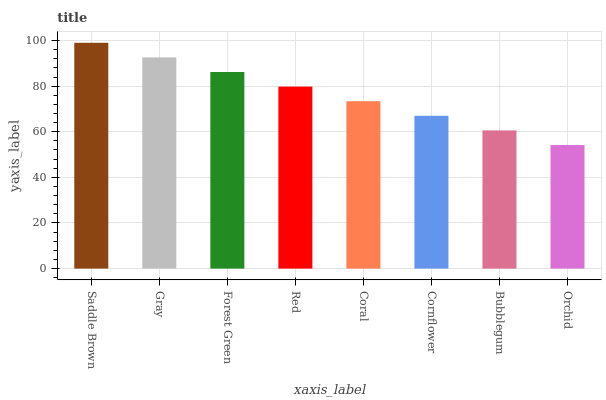Is Orchid the minimum?
Answer yes or no. Yes. Is Saddle Brown the maximum?
Answer yes or no. Yes. Is Gray the minimum?
Answer yes or no. No. Is Gray the maximum?
Answer yes or no. No. Is Saddle Brown greater than Gray?
Answer yes or no. Yes. Is Gray less than Saddle Brown?
Answer yes or no. Yes. Is Gray greater than Saddle Brown?
Answer yes or no. No. Is Saddle Brown less than Gray?
Answer yes or no. No. Is Red the high median?
Answer yes or no. Yes. Is Coral the low median?
Answer yes or no. Yes. Is Gray the high median?
Answer yes or no. No. Is Saddle Brown the low median?
Answer yes or no. No. 